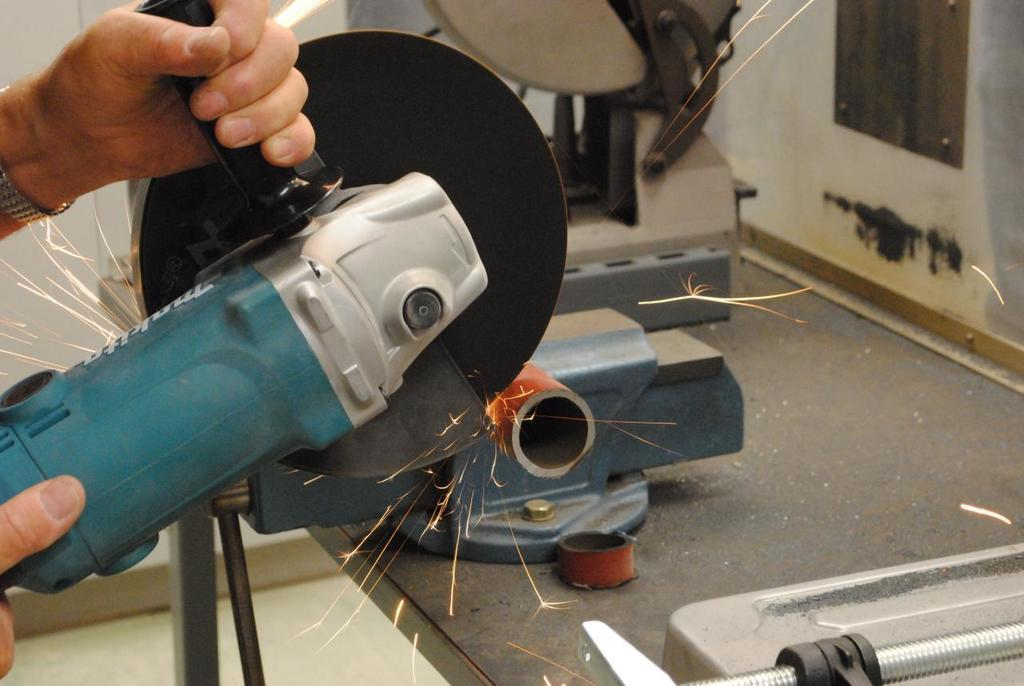What is the main subject of the image? There is a person in the image. What is the person holding in the image? The person's hand is holding a machine. Can you describe any accessories the person is wearing? The person is wearing a watch. What can be seen in the background of the image? There is a wall on the left side of the image. What is the source of the sparks of fire in the image? The sparks of fire are likely generated by the machine the person is holding. What type of mint is growing on the ground in the image? There is no mint or ground visible in the image; it features a person holding a machine with sparks of fire and a wall in the background. 